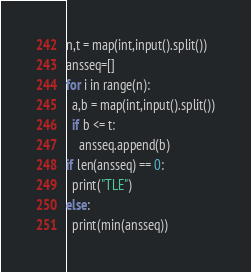Convert code to text. <code><loc_0><loc_0><loc_500><loc_500><_Python_>n,t = map(int,input().split())
ansseq=[]
for i in range(n):
  a,b = map(int,input().split())
  if b <= t:
    ansseq.append(b)
if len(ansseq) == 0:
  print("TLE")
else:
  print(min(ansseq))</code> 